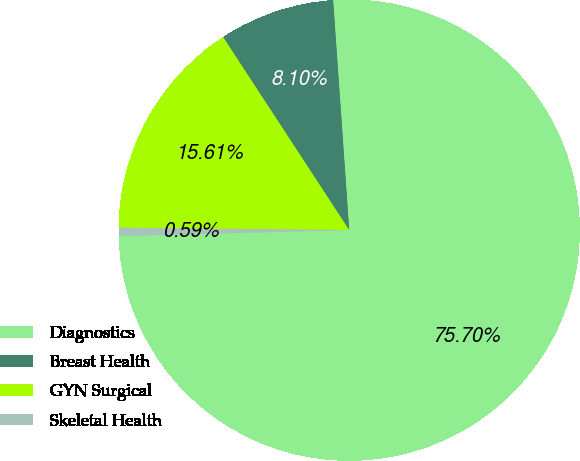<chart> <loc_0><loc_0><loc_500><loc_500><pie_chart><fcel>Diagnostics<fcel>Breast Health<fcel>GYN Surgical<fcel>Skeletal Health<nl><fcel>75.69%<fcel>8.1%<fcel>15.61%<fcel>0.59%<nl></chart> 